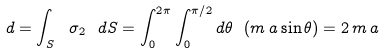Convert formula to latex. <formula><loc_0><loc_0><loc_500><loc_500>d = \int _ { S } \ \sigma _ { 2 } \ d S = \int ^ { 2 \pi } _ { 0 } \int ^ { \pi / 2 } _ { 0 } d \theta \ ( m \, a \sin \theta ) = 2 \, m \, a</formula> 